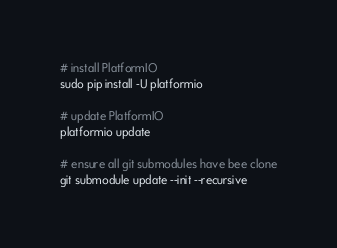<code> <loc_0><loc_0><loc_500><loc_500><_Bash_># install PlatformIO
sudo pip install -U platformio

# update PlatformIO
platformio update

# ensure all git submodules have bee clone
git submodule update --init --recursive
</code> 